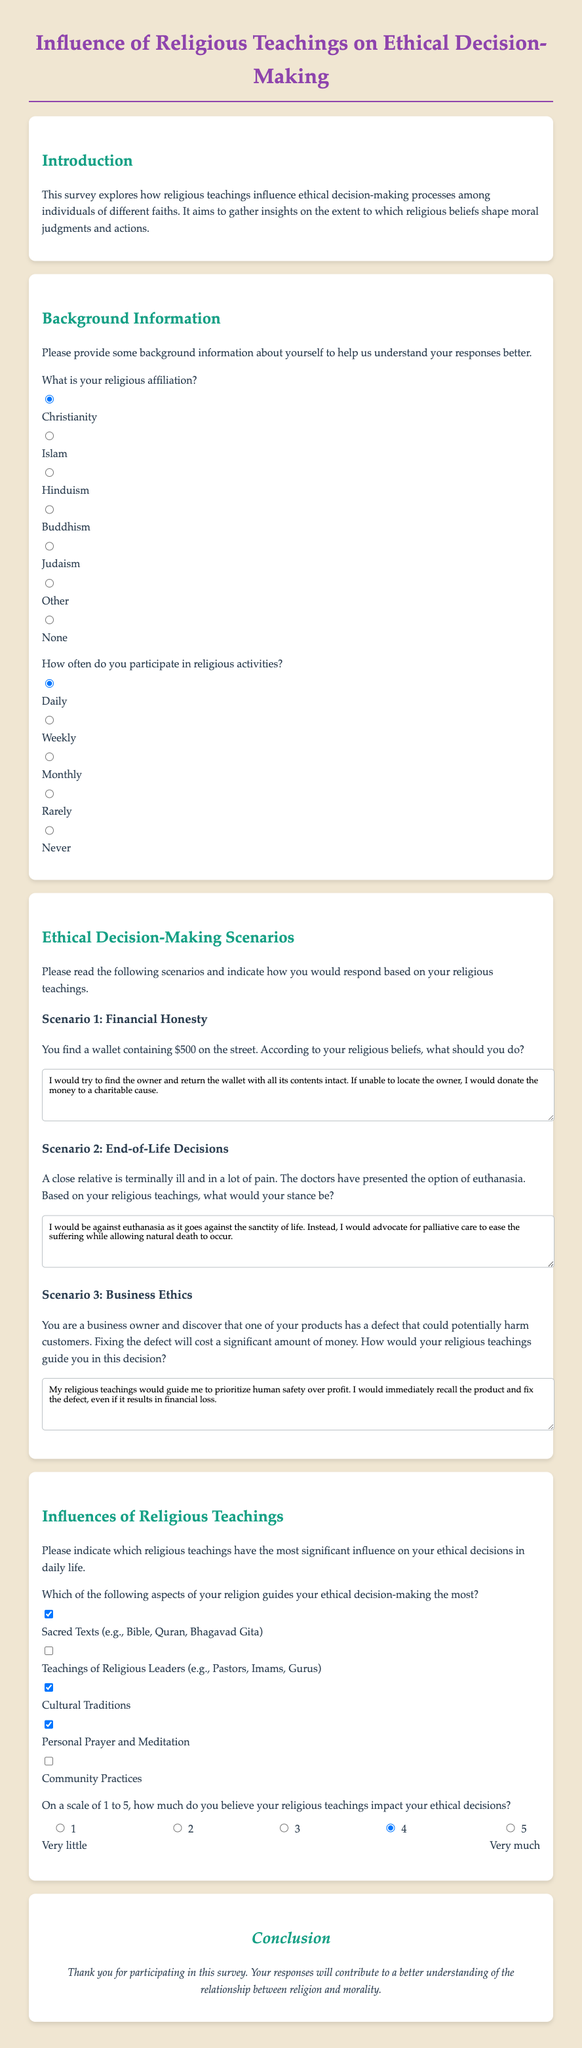What is the title of the survey? The title of the survey is presented at the top of the document.
Answer: Influence of Religious Teachings on Ethical Decision-Making What is the purpose of the survey? The purpose of the survey is outlined in the introduction section.
Answer: To explore how religious teachings influence ethical decision-making processes Which religious affiliation is pre-selected? The pre-selected option can be found in the background information section.
Answer: Christianity How often do respondents have the option to select "Rarely"? The options for participation frequency include multiple choices that describe various frequencies.
Answer: Rarely What is the first scenario presented in the survey? The first scenario relates to a situation regarding financial honesty.
Answer: Financial Honesty What scale is used to measure the impact of religious teachings on ethical decisions? The survey includes a scale rating system for gauging influences on decision-making.
Answer: 1 to 5 scale Which option is not listed as a religious teaching influence? The question regarding influences mentions several aspects of religion.
Answer: Community Practices On which aspect of religion is there a response checkbox for personal prayer? This is indicated in the influences of religious teachings section of the form.
Answer: Personal Prayer and Meditation What is emphasized in the conclusion section? The conclusion expresses gratitude for participation and aims to communicate the survey's significance.
Answer: Understanding the relationship between religion and morality 